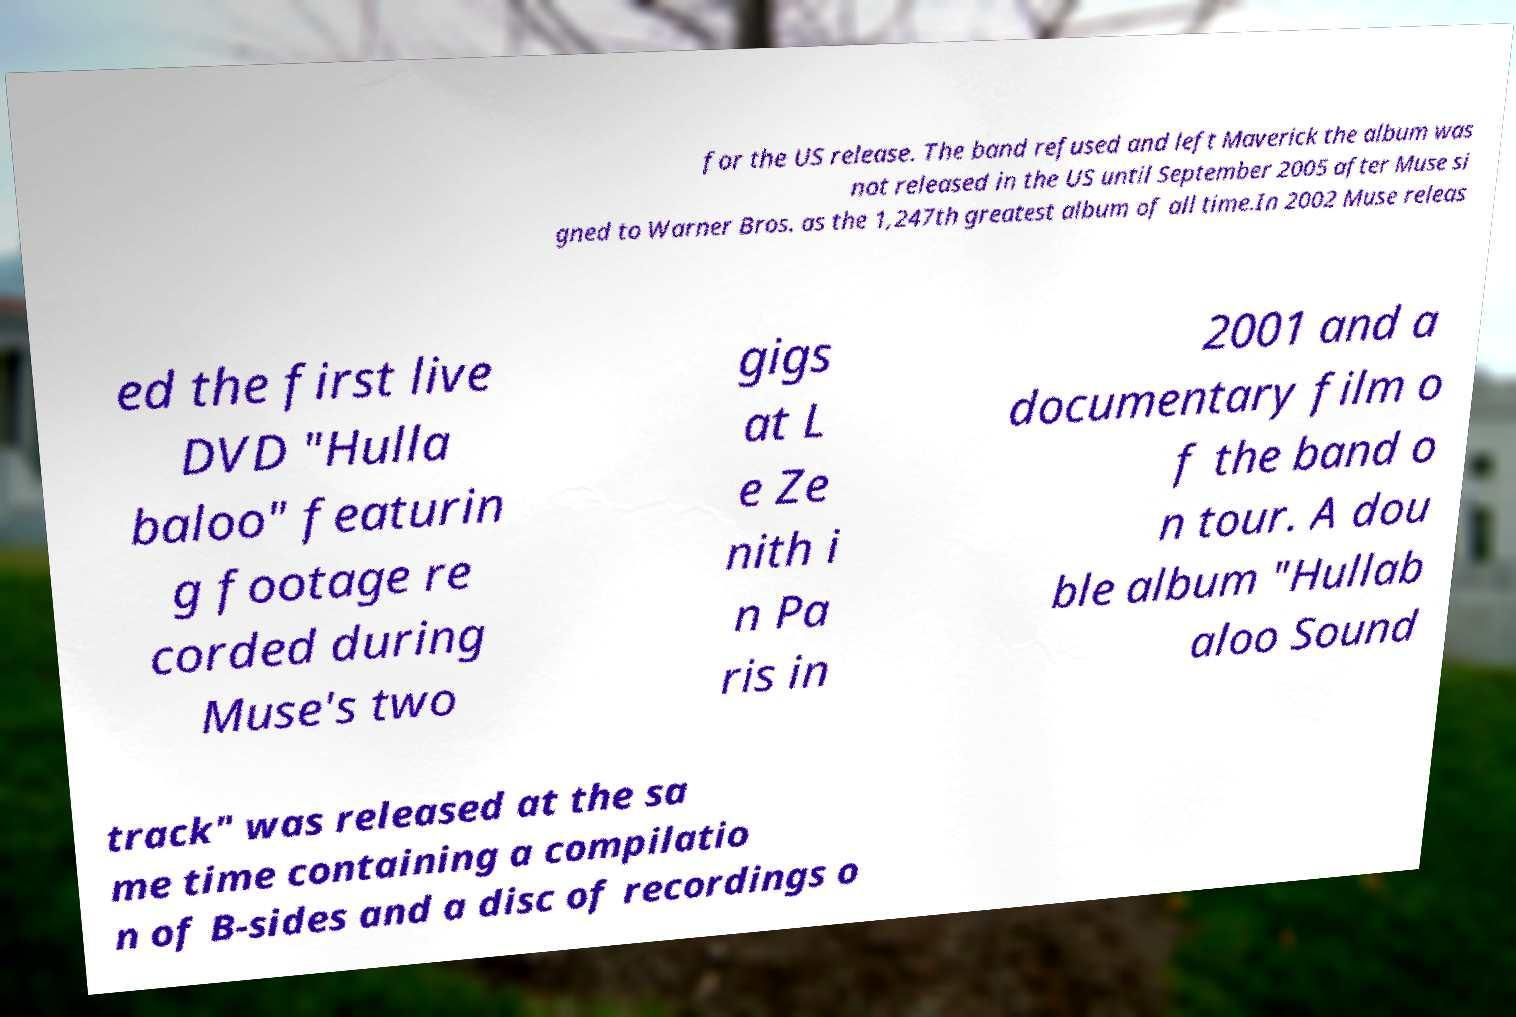What messages or text are displayed in this image? I need them in a readable, typed format. for the US release. The band refused and left Maverick the album was not released in the US until September 2005 after Muse si gned to Warner Bros. as the 1,247th greatest album of all time.In 2002 Muse releas ed the first live DVD "Hulla baloo" featurin g footage re corded during Muse's two gigs at L e Ze nith i n Pa ris in 2001 and a documentary film o f the band o n tour. A dou ble album "Hullab aloo Sound track" was released at the sa me time containing a compilatio n of B-sides and a disc of recordings o 